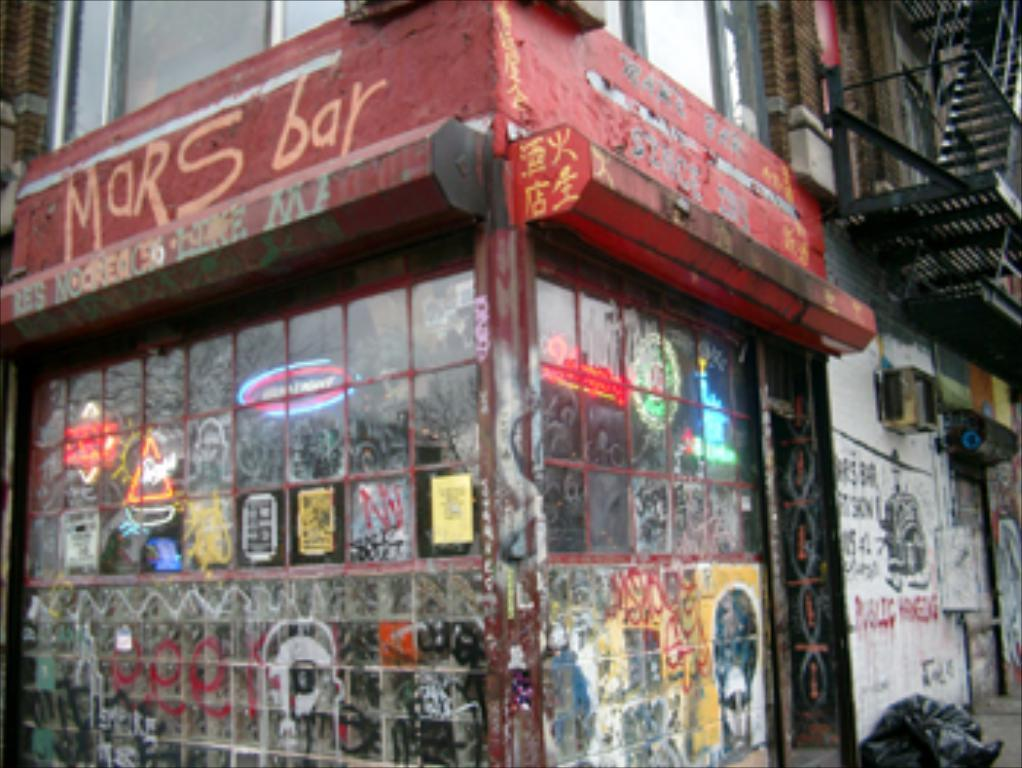What type of structure is visible in the image? There is a building in the image. What can be seen on the wall of the building? There is text on a wall in the image. What is present on the glass windows of the building? There are pictures on the glass windows in the image. What is located near the building? There is a signboard in the image. How can one access different floors of the building? There is a staircase in the image. What is the governor's profit from the building in the image? There is no information about a governor or profit in the image; it only shows a building with various features. 